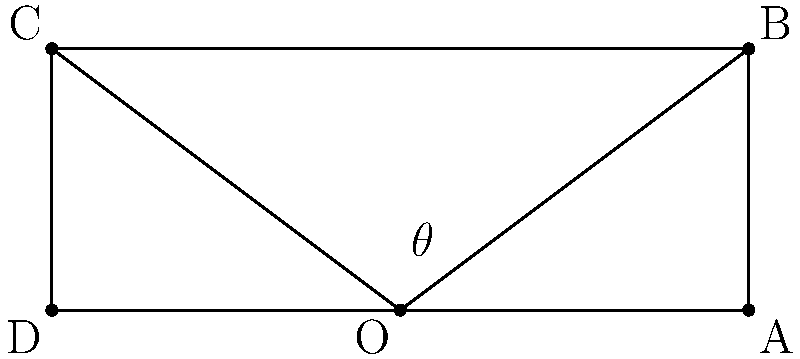You're testing a new wide-angle lens for your nature photography in a remote mountain range. The lens has a focal length of 15mm and is being used on a full-frame camera with a sensor width of 36mm. Using the diagram and trigonometry, calculate the horizontal angle of view ($\theta$) for this lens setup. To calculate the horizontal angle of view for a wide-angle lens, we can use the following steps:

1. Identify the known values:
   - Focal length (f) = 15mm
   - Sensor width (w) = 36mm

2. The angle of view formula for a rectilinear lens is:
   $$\theta = 2 \arctan(\frac{w}{2f})$$

3. Substitute the known values into the formula:
   $$\theta = 2 \arctan(\frac{36}{2 \cdot 15})$$

4. Simplify:
   $$\theta = 2 \arctan(\frac{18}{15})$$

5. Calculate the arctangent:
   $$\theta = 2 \arctan(1.2)$$
   $$\theta = 2 \cdot 0.8760 \text{ radians}$$

6. Convert radians to degrees:
   $$\theta = 1.7520 \cdot \frac{180}{\pi} \text{ degrees}$$
   $$\theta \approx 100.39 \text{ degrees}$$

Therefore, the horizontal angle of view for this wide-angle lens setup is approximately 100.39 degrees.
Answer: 100.39° 